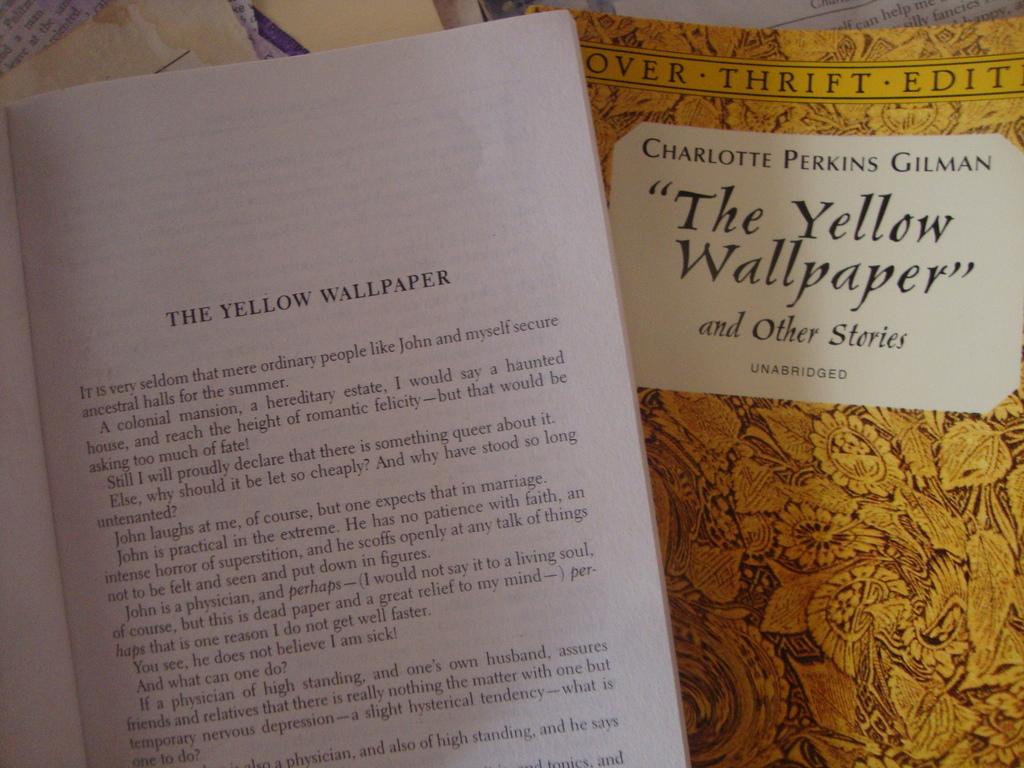Who is the author of this book?
Your response must be concise. Charlotte perkins gilman. 